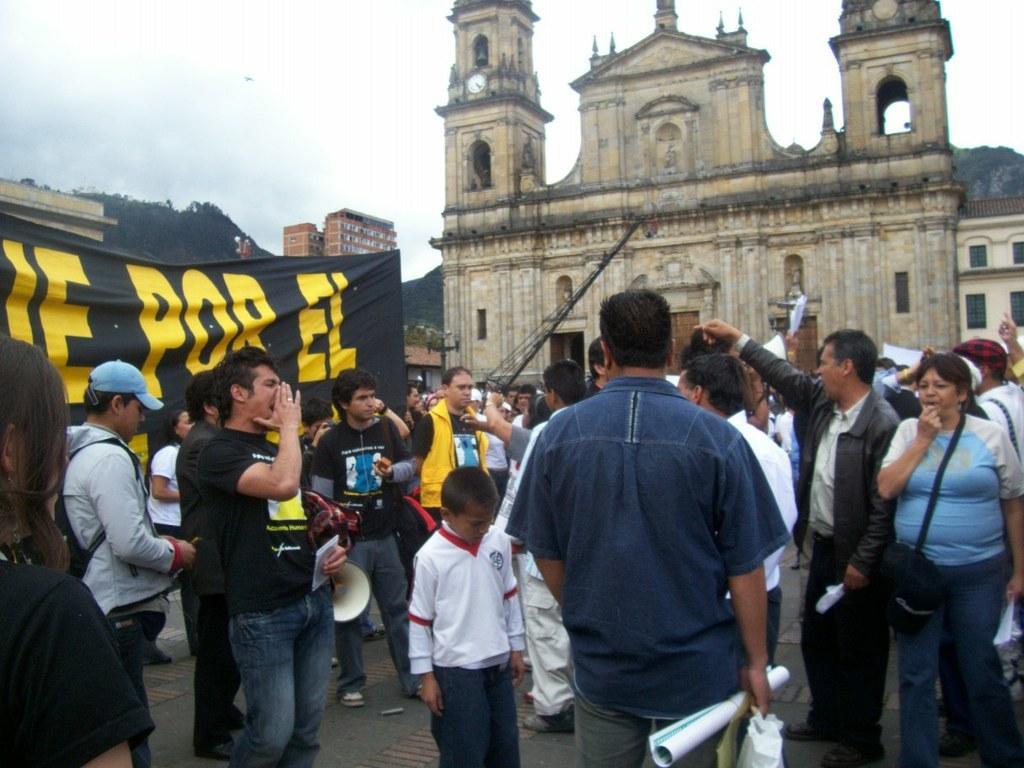Describe this image in one or two sentences. In the center of the image there are many people. In the background of the image there is a building. To the left side of the image there are people holding a black color banner. 